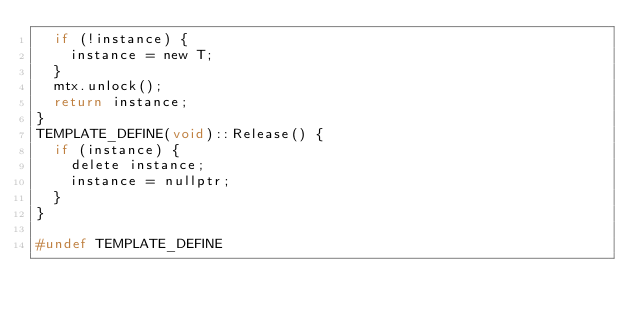Convert code to text. <code><loc_0><loc_0><loc_500><loc_500><_C_>	if (!instance) {
		instance = new T;
	}
	mtx.unlock();
	return instance;
}
TEMPLATE_DEFINE(void)::Release() {
	if (instance) {
		delete instance;
		instance = nullptr;
	}
}

#undef TEMPLATE_DEFINE</code> 